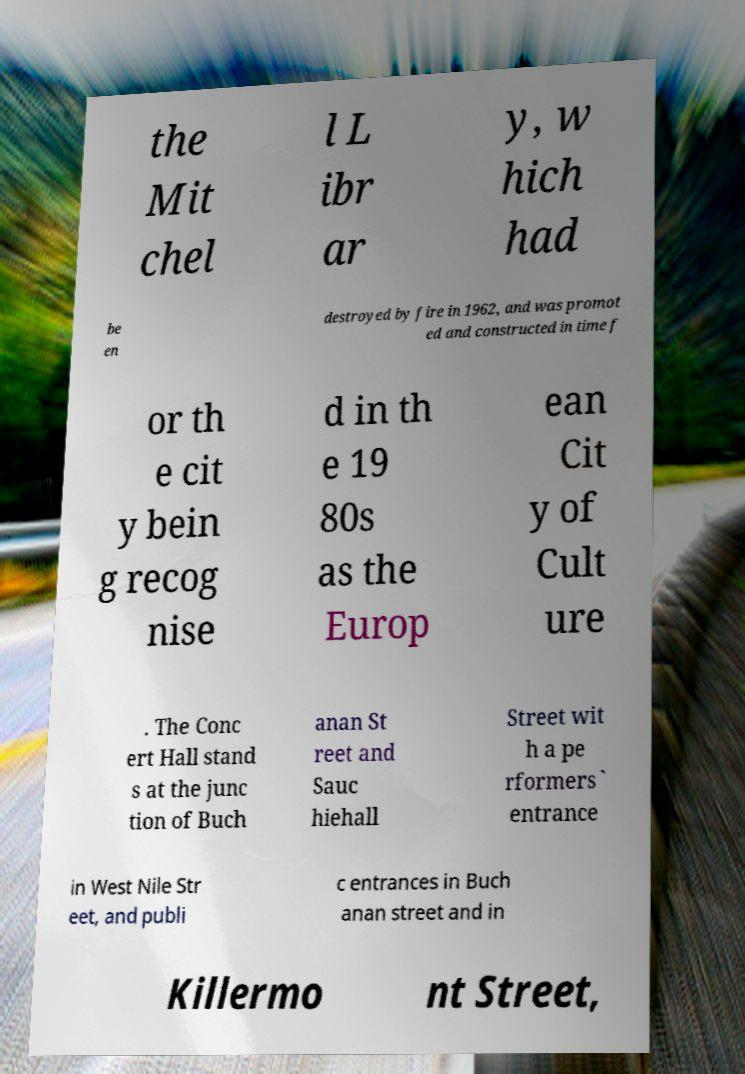Can you accurately transcribe the text from the provided image for me? the Mit chel l L ibr ar y, w hich had be en destroyed by fire in 1962, and was promot ed and constructed in time f or th e cit y bein g recog nise d in th e 19 80s as the Europ ean Cit y of Cult ure . The Conc ert Hall stand s at the junc tion of Buch anan St reet and Sauc hiehall Street wit h a pe rformers` entrance in West Nile Str eet, and publi c entrances in Buch anan street and in Killermo nt Street, 